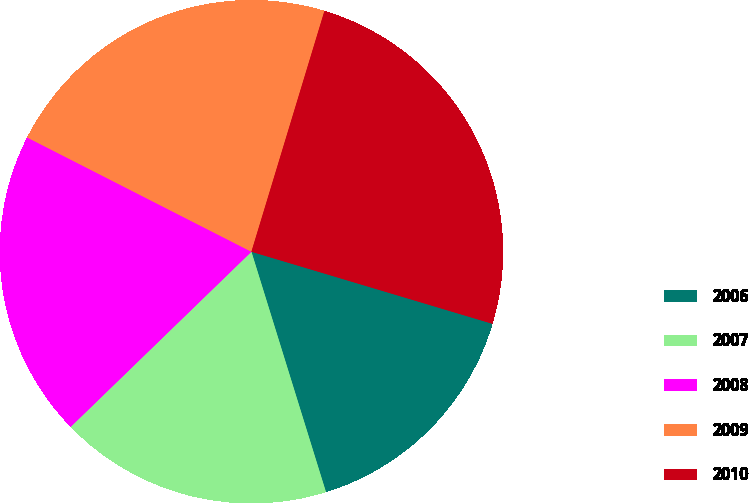Convert chart. <chart><loc_0><loc_0><loc_500><loc_500><pie_chart><fcel>2006<fcel>2007<fcel>2008<fcel>2009<fcel>2010<nl><fcel>15.59%<fcel>17.54%<fcel>19.75%<fcel>22.19%<fcel>24.94%<nl></chart> 